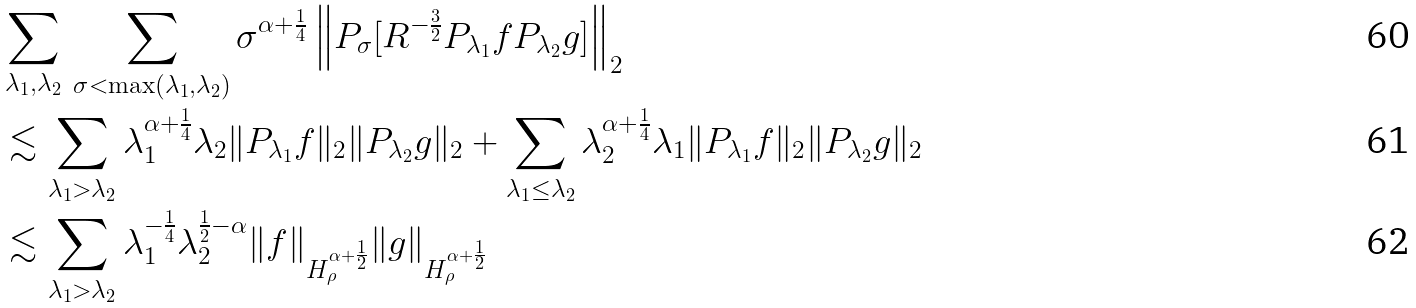Convert formula to latex. <formula><loc_0><loc_0><loc_500><loc_500>& \sum _ { \lambda _ { 1 } , \lambda _ { 2 } } \, \sum _ { \sigma < \max ( \lambda _ { 1 } , \lambda _ { 2 } ) } \sigma ^ { \alpha + \frac { 1 } { 4 } } \left \| P _ { \sigma } [ R ^ { - \frac { 3 } { 2 } } P _ { \lambda _ { 1 } } f P _ { \lambda _ { 2 } } g ] \right \| _ { 2 } \\ & \lesssim \sum _ { \lambda _ { 1 } > \lambda _ { 2 } } \lambda _ { 1 } ^ { \alpha + \frac { 1 } { 4 } } \lambda _ { 2 } \| P _ { \lambda _ { 1 } } f \| _ { 2 } \| P _ { \lambda _ { 2 } } g \| _ { 2 } + \sum _ { \lambda _ { 1 } \leq \lambda _ { 2 } } \lambda _ { 2 } ^ { \alpha + \frac { 1 } { 4 } } \lambda _ { 1 } \| P _ { \lambda _ { 1 } } f \| _ { 2 } \| P _ { \lambda _ { 2 } } g \| _ { 2 } \\ & \lesssim \sum _ { \lambda _ { 1 } > \lambda _ { 2 } } \lambda _ { 1 } ^ { - \frac { 1 } { 4 } } \lambda _ { 2 } ^ { \frac { 1 } { 2 } - \alpha } \| f \| _ { H _ { \rho } ^ { \alpha + \frac { 1 } { 2 } } } \| g \| _ { H _ { \rho } ^ { \alpha + \frac { 1 } { 2 } } }</formula> 